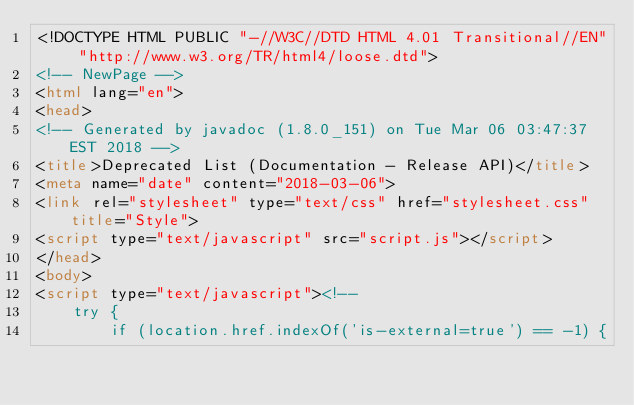Convert code to text. <code><loc_0><loc_0><loc_500><loc_500><_HTML_><!DOCTYPE HTML PUBLIC "-//W3C//DTD HTML 4.01 Transitional//EN" "http://www.w3.org/TR/html4/loose.dtd">
<!-- NewPage -->
<html lang="en">
<head>
<!-- Generated by javadoc (1.8.0_151) on Tue Mar 06 03:47:37 EST 2018 -->
<title>Deprecated List (Documentation - Release API)</title>
<meta name="date" content="2018-03-06">
<link rel="stylesheet" type="text/css" href="stylesheet.css" title="Style">
<script type="text/javascript" src="script.js"></script>
</head>
<body>
<script type="text/javascript"><!--
    try {
        if (location.href.indexOf('is-external=true') == -1) {</code> 